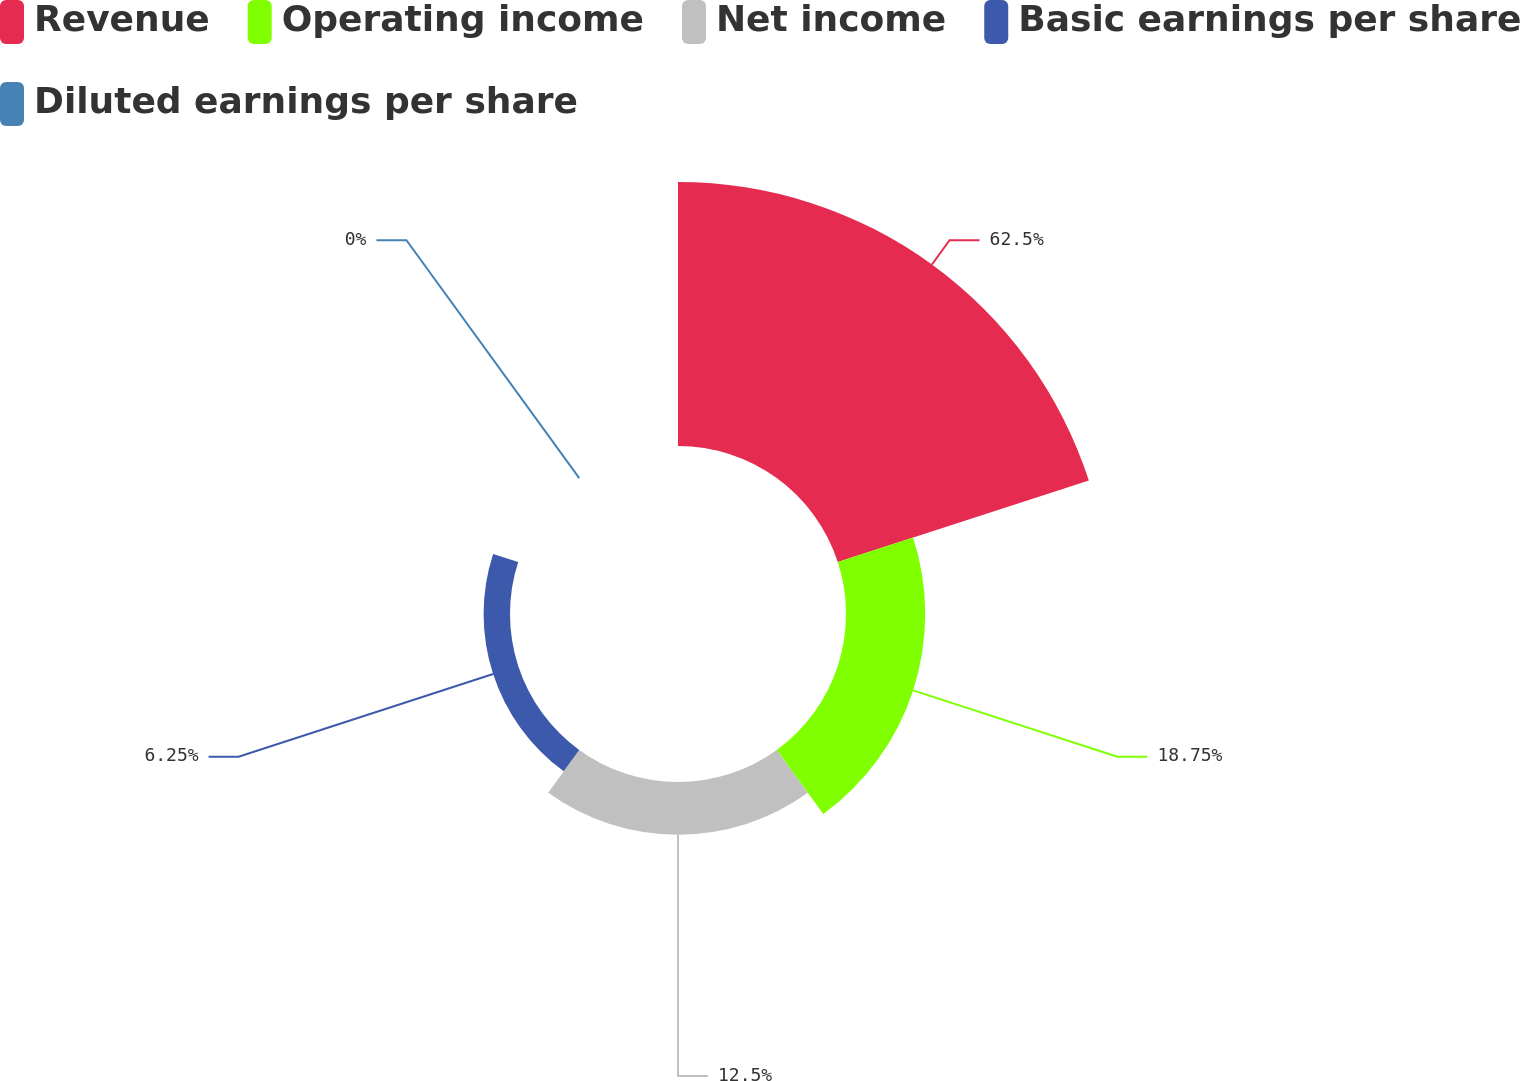Convert chart. <chart><loc_0><loc_0><loc_500><loc_500><pie_chart><fcel>Revenue<fcel>Operating income<fcel>Net income<fcel>Basic earnings per share<fcel>Diluted earnings per share<nl><fcel>62.5%<fcel>18.75%<fcel>12.5%<fcel>6.25%<fcel>0.0%<nl></chart> 